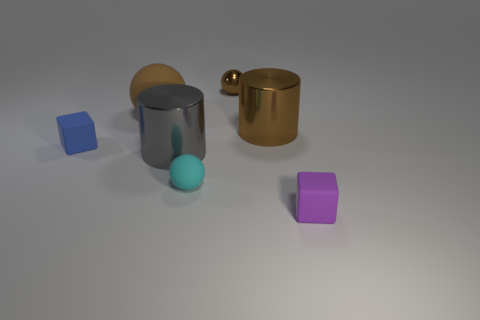Are there fewer brown rubber things that are to the right of the tiny cyan rubber object than brown metal cylinders behind the big brown metal cylinder?
Provide a short and direct response. No. Do the gray thing and the small block that is to the right of the brown metallic ball have the same material?
Your answer should be very brief. No. Is the number of blue metal cubes greater than the number of tiny shiny objects?
Give a very brief answer. No. What is the shape of the big gray thing to the left of the tiny sphere that is in front of the tiny sphere that is behind the blue cube?
Make the answer very short. Cylinder. Is the material of the large thing on the right side of the cyan ball the same as the brown ball in front of the tiny metallic sphere?
Make the answer very short. No. There is a cyan thing that is the same material as the tiny blue object; what is its shape?
Provide a succinct answer. Sphere. Is there anything else that is the same color as the small matte sphere?
Give a very brief answer. No. What number of tiny red rubber cylinders are there?
Provide a short and direct response. 0. What material is the cylinder in front of the rubber block that is behind the tiny purple object?
Offer a very short reply. Metal. What color is the cylinder that is in front of the blue matte block to the left of the cube that is in front of the tiny blue matte cube?
Offer a very short reply. Gray. 